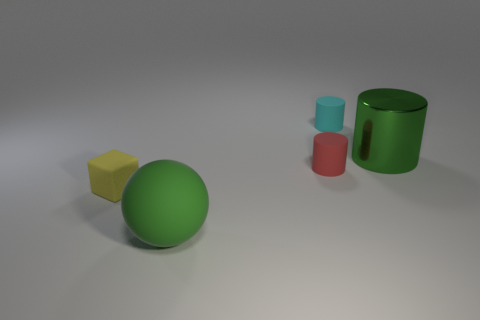What size is the cylinder that is behind the shiny cylinder?
Offer a very short reply. Small. How many purple things are either tiny matte objects or big shiny objects?
Your answer should be very brief. 0. Are there any other things that have the same material as the tiny cyan cylinder?
Your answer should be compact. Yes. There is a small cyan thing that is the same shape as the tiny red object; what is its material?
Give a very brief answer. Rubber. Is the number of small cyan rubber things that are behind the cyan matte object the same as the number of tiny red objects?
Make the answer very short. No. What size is the cylinder that is in front of the small cyan matte object and on the left side of the large green shiny thing?
Give a very brief answer. Small. Is there any other thing of the same color as the large rubber thing?
Your answer should be very brief. Yes. There is a object to the left of the green thing in front of the block; what is its size?
Give a very brief answer. Small. What color is the object that is behind the tiny red cylinder and left of the green cylinder?
Offer a terse response. Cyan. What number of other things are the same size as the shiny cylinder?
Make the answer very short. 1. 